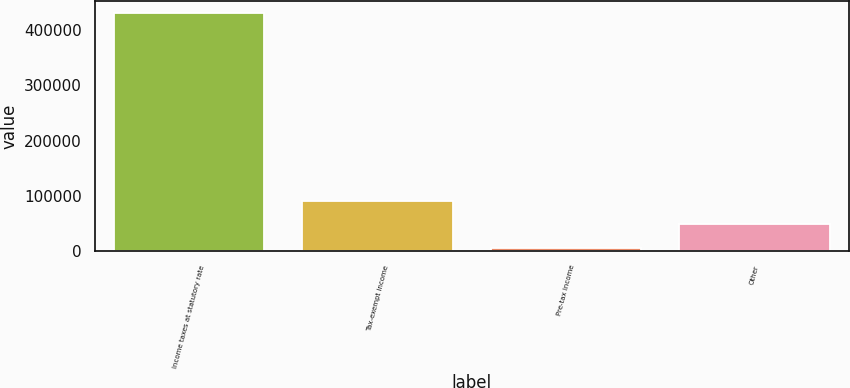Convert chart to OTSL. <chart><loc_0><loc_0><loc_500><loc_500><bar_chart><fcel>Income taxes at statutory rate<fcel>Tax-exempt income<fcel>Pre-tax income<fcel>Other<nl><fcel>431075<fcel>91311.8<fcel>6371<fcel>48841.4<nl></chart> 